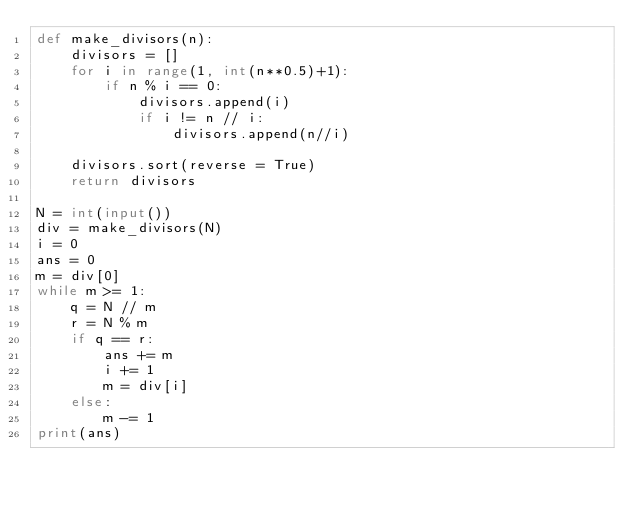Convert code to text. <code><loc_0><loc_0><loc_500><loc_500><_Python_>def make_divisors(n):
	divisors = []
	for i in range(1, int(n**0.5)+1):
		if n % i == 0:
			divisors.append(i)
			if i != n // i:
				divisors.append(n//i)

	divisors.sort(reverse = True)
	return divisors

N = int(input())
div = make_divisors(N)
i = 0
ans = 0
m = div[0]
while m >= 1:
	q = N // m
	r = N % m
	if q == r:
		ans += m
		i += 1
		m = div[i]
	else:
		m -= 1
print(ans)
</code> 